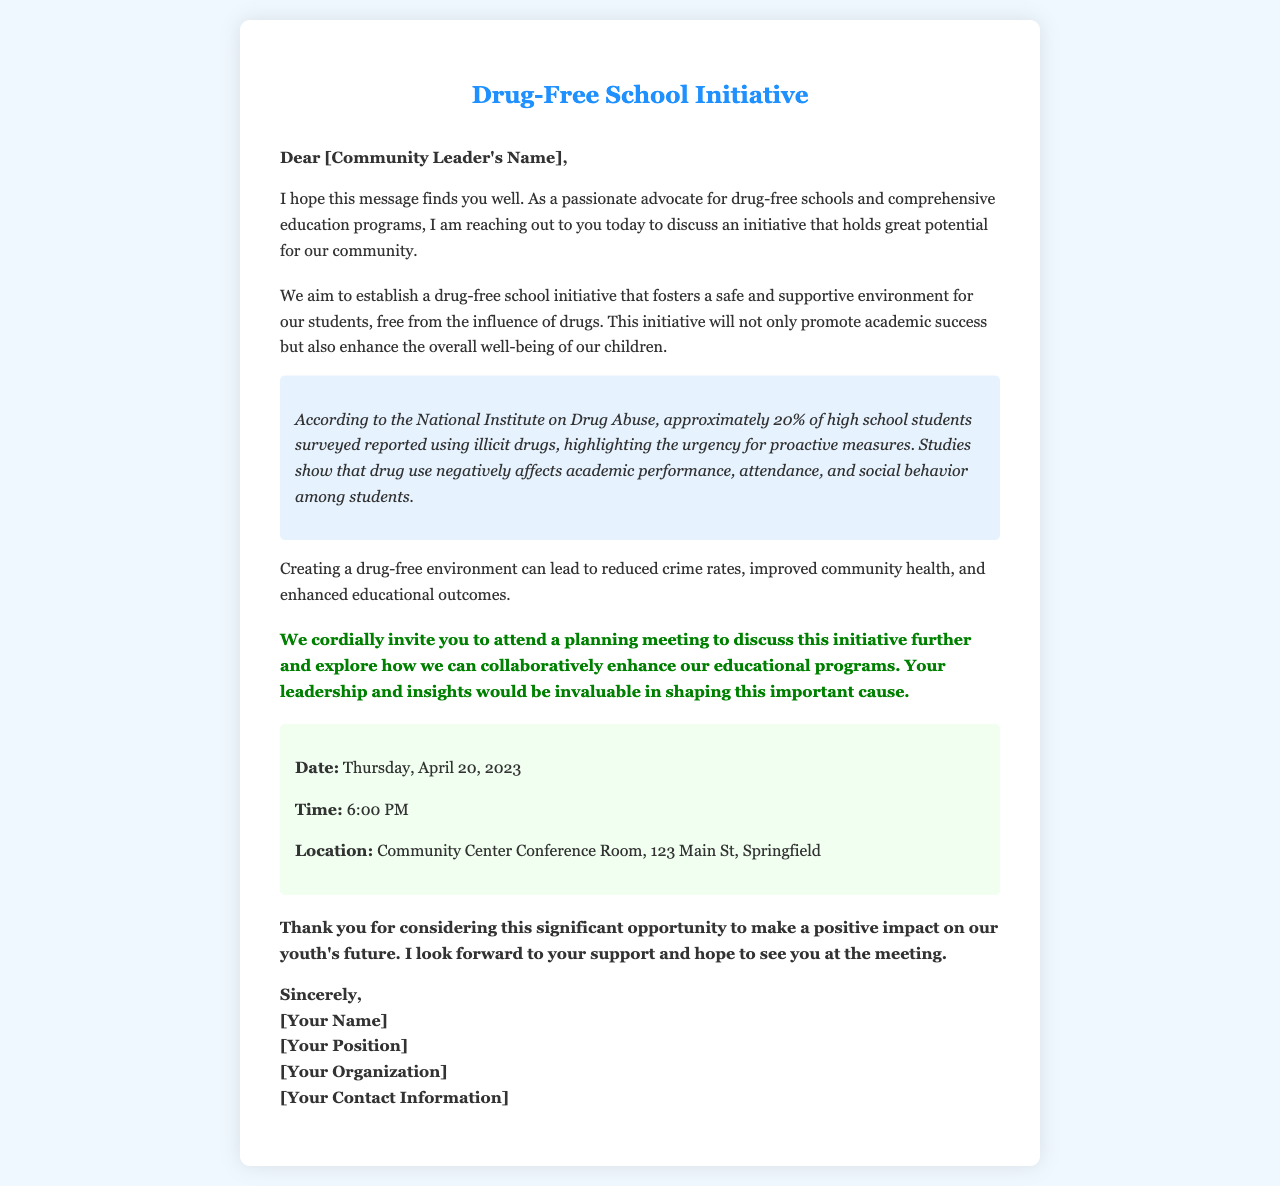What is the initiative discussed in the letter? The initiative discussed is to establish a drug-free school initiative that fosters a safe environment for students.
Answer: drug-free school initiative Who is the letter addressed to? The letter is addressed to community leaders, specifically mentioning [Community Leader's Name].
Answer: [Community Leader's Name] What is the date of the planning meeting? The planning meeting is scheduled for Thursday, April 20, 2023.
Answer: Thursday, April 20, 2023 What time is the planning meeting? The planning meeting is set to begin at 6:00 PM.
Answer: 6:00 PM Where will the meeting take place? The meeting will take place at the Community Center Conference Room, 123 Main St, Springfield.
Answer: Community Center Conference Room, 123 Main St, Springfield According to the document, what percentage of high school students reported using illicit drugs? The document states that approximately 20% of high school students surveyed reported using illicit drugs.
Answer: 20% What potential benefits does a drug-free environment provide? A drug-free environment can lead to reduced crime rates, improved community health, and enhanced educational outcomes.
Answer: reduced crime rates, improved community health, enhanced educational outcomes What does the author request from the community leader? The author requests the community leader's support and invites them to the planning meeting to discuss the initiative further.
Answer: support and attendance at the meeting What role does the author claim to have? The author identifies themselves as a passionate advocate for drug-free schools and education programs.
Answer: advocate for drug-free schools and education programs 